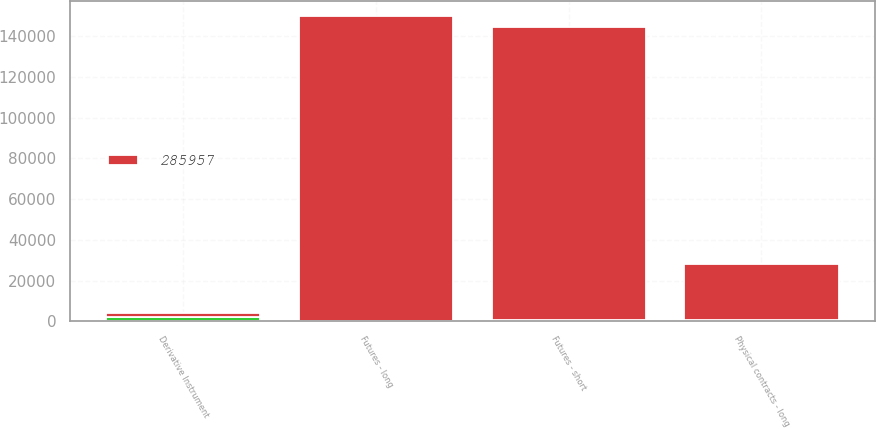Convert chart to OTSL. <chart><loc_0><loc_0><loc_500><loc_500><stacked_bar_chart><ecel><fcel>Derivative Instrument<fcel>Futures - long<fcel>Futures - short<fcel>Physical contracts - long<nl><fcel>285957<fcel>2019<fcel>149470<fcel>143826<fcel>27109<nl><fcel>nan<fcel>2020<fcel>224<fcel>671<fcel>875<nl></chart> 